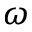Convert formula to latex. <formula><loc_0><loc_0><loc_500><loc_500>\omega</formula> 